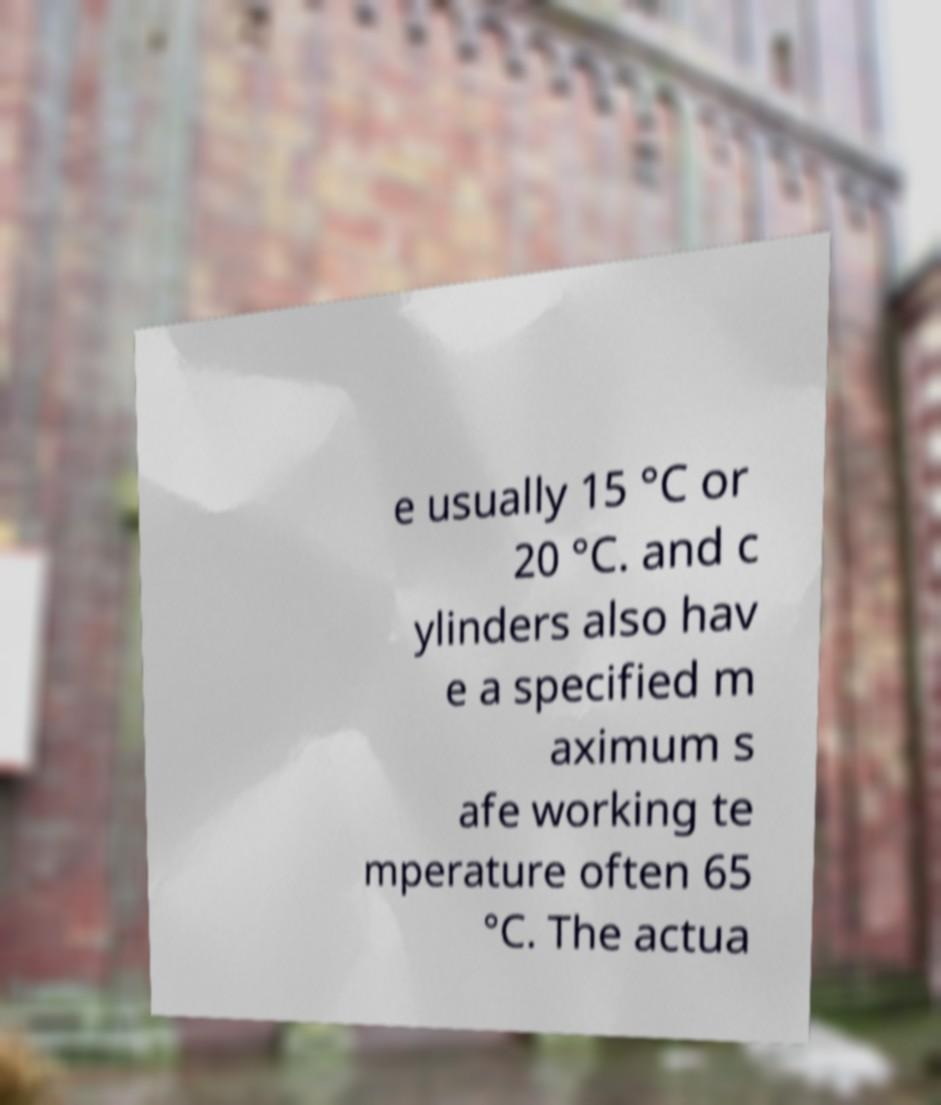For documentation purposes, I need the text within this image transcribed. Could you provide that? e usually 15 °C or 20 °C. and c ylinders also hav e a specified m aximum s afe working te mperature often 65 °C. The actua 